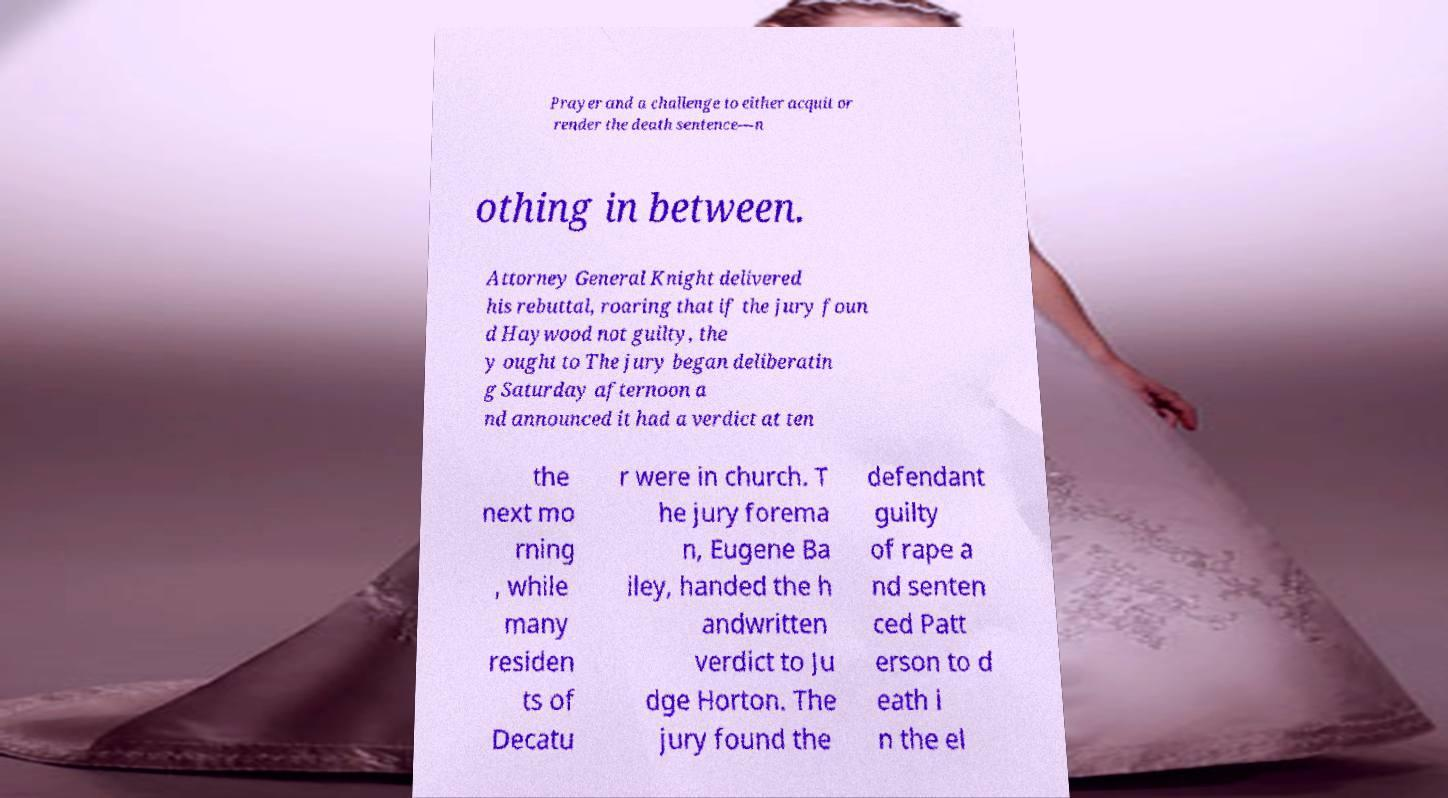Could you assist in decoding the text presented in this image and type it out clearly? Prayer and a challenge to either acquit or render the death sentence—n othing in between. Attorney General Knight delivered his rebuttal, roaring that if the jury foun d Haywood not guilty, the y ought to The jury began deliberatin g Saturday afternoon a nd announced it had a verdict at ten the next mo rning , while many residen ts of Decatu r were in church. T he jury forema n, Eugene Ba iley, handed the h andwritten verdict to Ju dge Horton. The jury found the defendant guilty of rape a nd senten ced Patt erson to d eath i n the el 